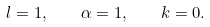Convert formula to latex. <formula><loc_0><loc_0><loc_500><loc_500>l = 1 , \quad \alpha = 1 , \quad k = 0 .</formula> 